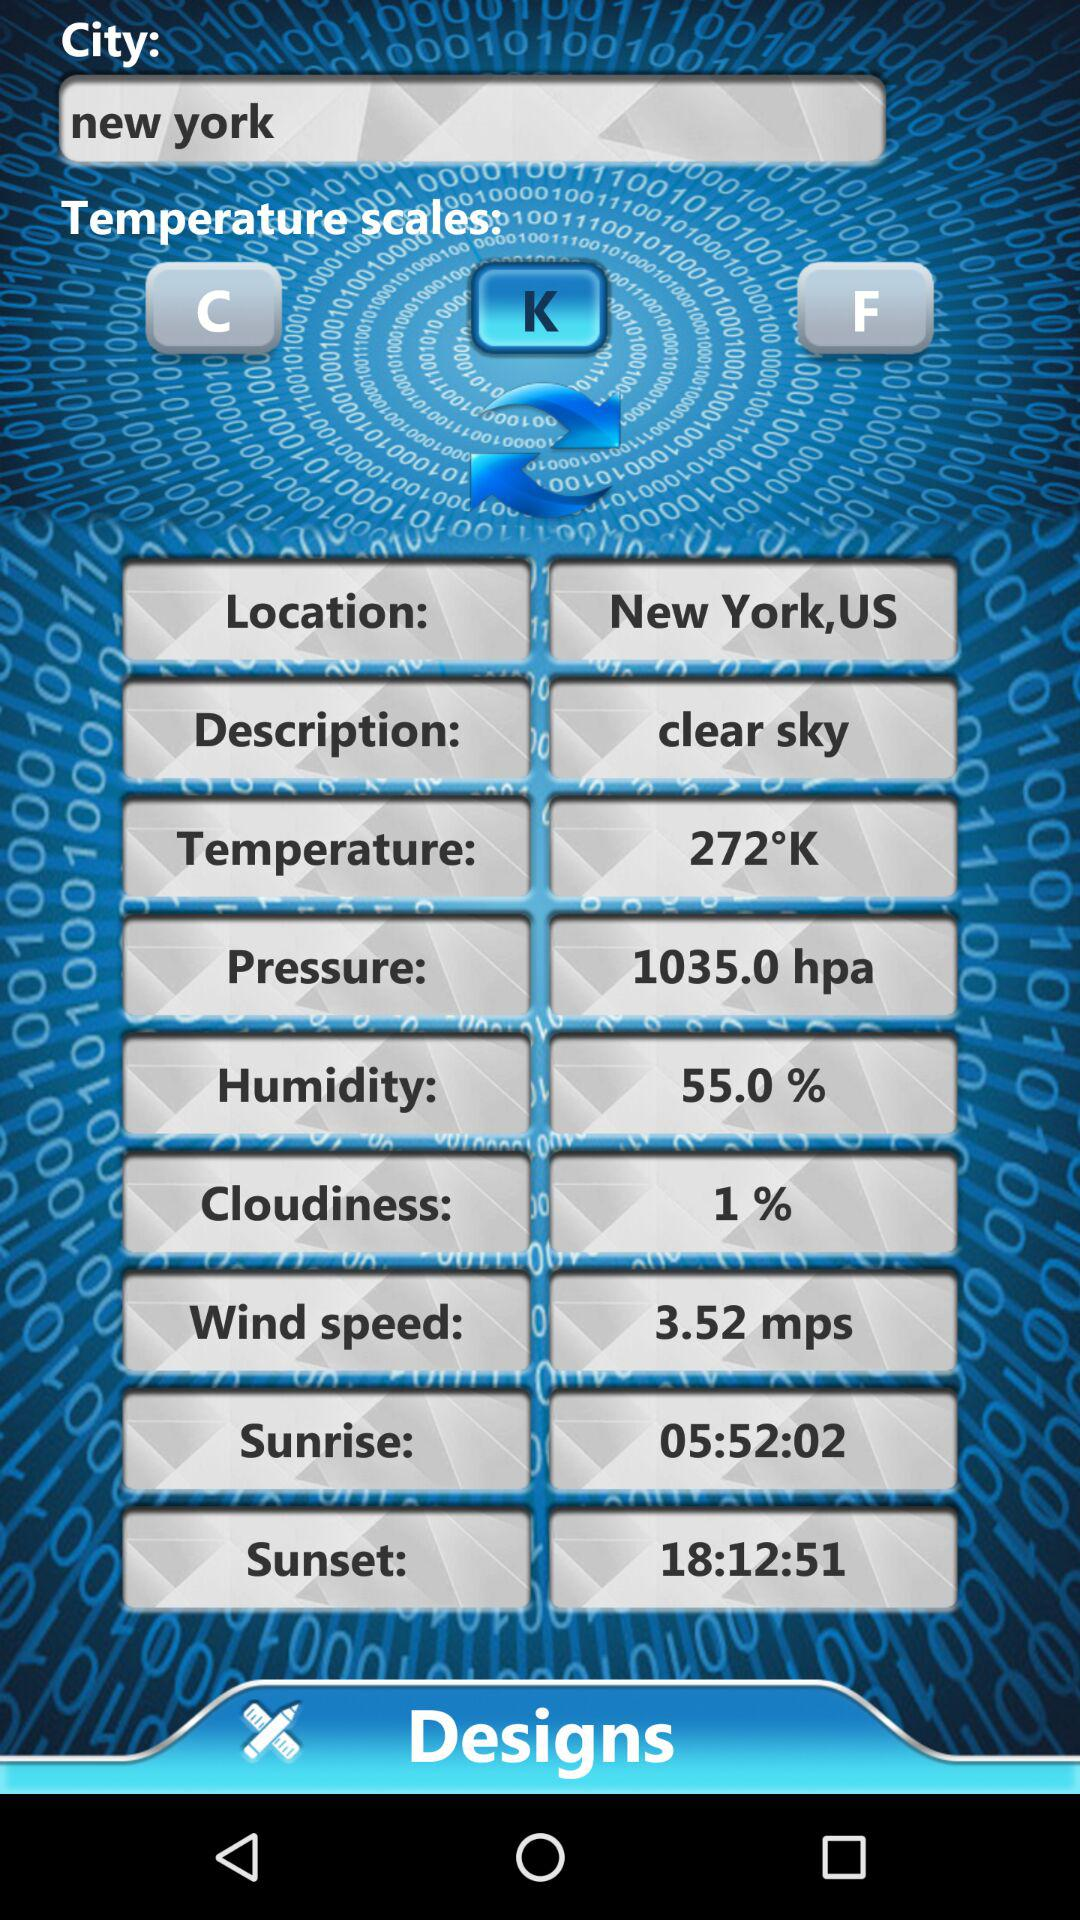What is the wind speed? The wind speed is 3.52 mps. 